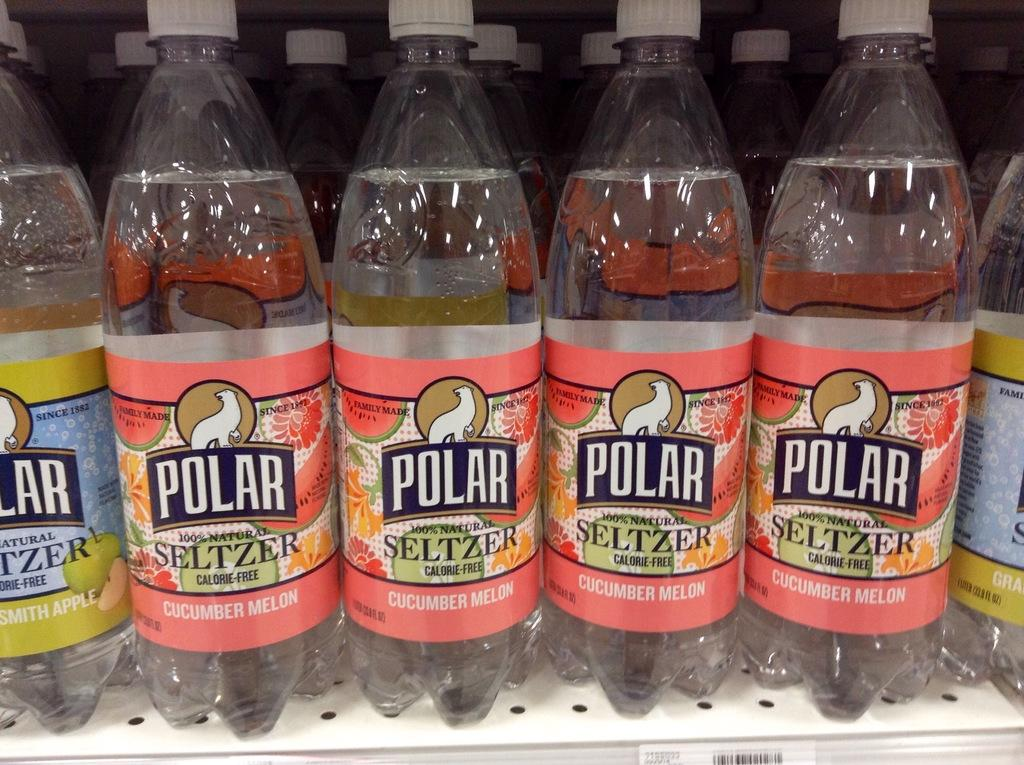What objects are visible in the image? There are water bottles in the image. Where are the water bottles located? The water bottles are placed in a shelf. What type of car is visible in the image? There is no car present in the image. Is there a camera visible in the image? There is no camera present in the image. What type of art can be seen in the image? There is no art present in the image. 